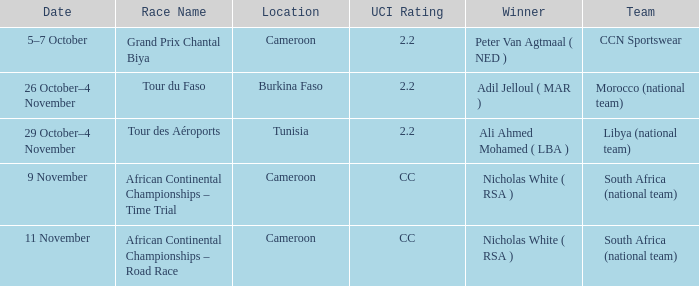Who is the champion of the race in burkina faso? Adil Jelloul ( MAR ). 